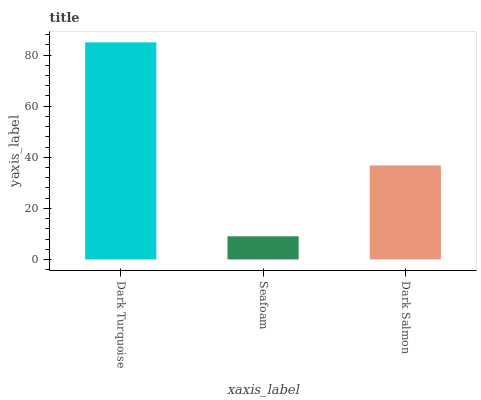Is Seafoam the minimum?
Answer yes or no. Yes. Is Dark Turquoise the maximum?
Answer yes or no. Yes. Is Dark Salmon the minimum?
Answer yes or no. No. Is Dark Salmon the maximum?
Answer yes or no. No. Is Dark Salmon greater than Seafoam?
Answer yes or no. Yes. Is Seafoam less than Dark Salmon?
Answer yes or no. Yes. Is Seafoam greater than Dark Salmon?
Answer yes or no. No. Is Dark Salmon less than Seafoam?
Answer yes or no. No. Is Dark Salmon the high median?
Answer yes or no. Yes. Is Dark Salmon the low median?
Answer yes or no. Yes. Is Seafoam the high median?
Answer yes or no. No. Is Dark Turquoise the low median?
Answer yes or no. No. 